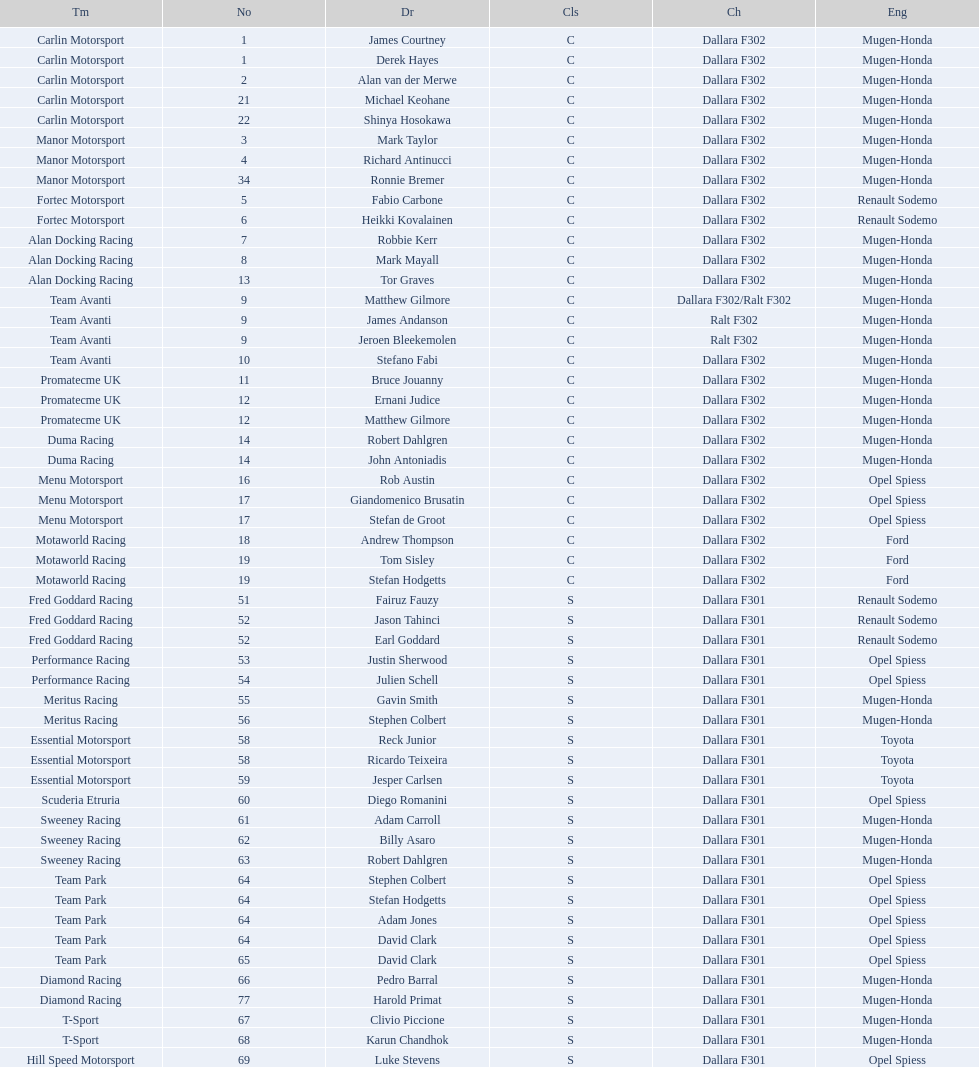Would you mind parsing the complete table? {'header': ['Tm', 'No', 'Dr', 'Cls', 'Ch', 'Eng'], 'rows': [['Carlin Motorsport', '1', 'James Courtney', 'C', 'Dallara F302', 'Mugen-Honda'], ['Carlin Motorsport', '1', 'Derek Hayes', 'C', 'Dallara F302', 'Mugen-Honda'], ['Carlin Motorsport', '2', 'Alan van der Merwe', 'C', 'Dallara F302', 'Mugen-Honda'], ['Carlin Motorsport', '21', 'Michael Keohane', 'C', 'Dallara F302', 'Mugen-Honda'], ['Carlin Motorsport', '22', 'Shinya Hosokawa', 'C', 'Dallara F302', 'Mugen-Honda'], ['Manor Motorsport', '3', 'Mark Taylor', 'C', 'Dallara F302', 'Mugen-Honda'], ['Manor Motorsport', '4', 'Richard Antinucci', 'C', 'Dallara F302', 'Mugen-Honda'], ['Manor Motorsport', '34', 'Ronnie Bremer', 'C', 'Dallara F302', 'Mugen-Honda'], ['Fortec Motorsport', '5', 'Fabio Carbone', 'C', 'Dallara F302', 'Renault Sodemo'], ['Fortec Motorsport', '6', 'Heikki Kovalainen', 'C', 'Dallara F302', 'Renault Sodemo'], ['Alan Docking Racing', '7', 'Robbie Kerr', 'C', 'Dallara F302', 'Mugen-Honda'], ['Alan Docking Racing', '8', 'Mark Mayall', 'C', 'Dallara F302', 'Mugen-Honda'], ['Alan Docking Racing', '13', 'Tor Graves', 'C', 'Dallara F302', 'Mugen-Honda'], ['Team Avanti', '9', 'Matthew Gilmore', 'C', 'Dallara F302/Ralt F302', 'Mugen-Honda'], ['Team Avanti', '9', 'James Andanson', 'C', 'Ralt F302', 'Mugen-Honda'], ['Team Avanti', '9', 'Jeroen Bleekemolen', 'C', 'Ralt F302', 'Mugen-Honda'], ['Team Avanti', '10', 'Stefano Fabi', 'C', 'Dallara F302', 'Mugen-Honda'], ['Promatecme UK', '11', 'Bruce Jouanny', 'C', 'Dallara F302', 'Mugen-Honda'], ['Promatecme UK', '12', 'Ernani Judice', 'C', 'Dallara F302', 'Mugen-Honda'], ['Promatecme UK', '12', 'Matthew Gilmore', 'C', 'Dallara F302', 'Mugen-Honda'], ['Duma Racing', '14', 'Robert Dahlgren', 'C', 'Dallara F302', 'Mugen-Honda'], ['Duma Racing', '14', 'John Antoniadis', 'C', 'Dallara F302', 'Mugen-Honda'], ['Menu Motorsport', '16', 'Rob Austin', 'C', 'Dallara F302', 'Opel Spiess'], ['Menu Motorsport', '17', 'Giandomenico Brusatin', 'C', 'Dallara F302', 'Opel Spiess'], ['Menu Motorsport', '17', 'Stefan de Groot', 'C', 'Dallara F302', 'Opel Spiess'], ['Motaworld Racing', '18', 'Andrew Thompson', 'C', 'Dallara F302', 'Ford'], ['Motaworld Racing', '19', 'Tom Sisley', 'C', 'Dallara F302', 'Ford'], ['Motaworld Racing', '19', 'Stefan Hodgetts', 'C', 'Dallara F302', 'Ford'], ['Fred Goddard Racing', '51', 'Fairuz Fauzy', 'S', 'Dallara F301', 'Renault Sodemo'], ['Fred Goddard Racing', '52', 'Jason Tahinci', 'S', 'Dallara F301', 'Renault Sodemo'], ['Fred Goddard Racing', '52', 'Earl Goddard', 'S', 'Dallara F301', 'Renault Sodemo'], ['Performance Racing', '53', 'Justin Sherwood', 'S', 'Dallara F301', 'Opel Spiess'], ['Performance Racing', '54', 'Julien Schell', 'S', 'Dallara F301', 'Opel Spiess'], ['Meritus Racing', '55', 'Gavin Smith', 'S', 'Dallara F301', 'Mugen-Honda'], ['Meritus Racing', '56', 'Stephen Colbert', 'S', 'Dallara F301', 'Mugen-Honda'], ['Essential Motorsport', '58', 'Reck Junior', 'S', 'Dallara F301', 'Toyota'], ['Essential Motorsport', '58', 'Ricardo Teixeira', 'S', 'Dallara F301', 'Toyota'], ['Essential Motorsport', '59', 'Jesper Carlsen', 'S', 'Dallara F301', 'Toyota'], ['Scuderia Etruria', '60', 'Diego Romanini', 'S', 'Dallara F301', 'Opel Spiess'], ['Sweeney Racing', '61', 'Adam Carroll', 'S', 'Dallara F301', 'Mugen-Honda'], ['Sweeney Racing', '62', 'Billy Asaro', 'S', 'Dallara F301', 'Mugen-Honda'], ['Sweeney Racing', '63', 'Robert Dahlgren', 'S', 'Dallara F301', 'Mugen-Honda'], ['Team Park', '64', 'Stephen Colbert', 'S', 'Dallara F301', 'Opel Spiess'], ['Team Park', '64', 'Stefan Hodgetts', 'S', 'Dallara F301', 'Opel Spiess'], ['Team Park', '64', 'Adam Jones', 'S', 'Dallara F301', 'Opel Spiess'], ['Team Park', '64', 'David Clark', 'S', 'Dallara F301', 'Opel Spiess'], ['Team Park', '65', 'David Clark', 'S', 'Dallara F301', 'Opel Spiess'], ['Diamond Racing', '66', 'Pedro Barral', 'S', 'Dallara F301', 'Mugen-Honda'], ['Diamond Racing', '77', 'Harold Primat', 'S', 'Dallara F301', 'Mugen-Honda'], ['T-Sport', '67', 'Clivio Piccione', 'S', 'Dallara F301', 'Mugen-Honda'], ['T-Sport', '68', 'Karun Chandhok', 'S', 'Dallara F301', 'Mugen-Honda'], ['Hill Speed Motorsport', '69', 'Luke Stevens', 'S', 'Dallara F301', 'Opel Spiess']]} What is the total number of class c (championship) teams? 21. 